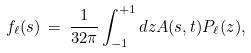Convert formula to latex. <formula><loc_0><loc_0><loc_500><loc_500>f _ { \ell } ( s ) \, = \, \frac { 1 } { 3 2 \pi } \int _ { - 1 } ^ { + 1 } d z A ( s , t ) P _ { \ell } ( z ) ,</formula> 